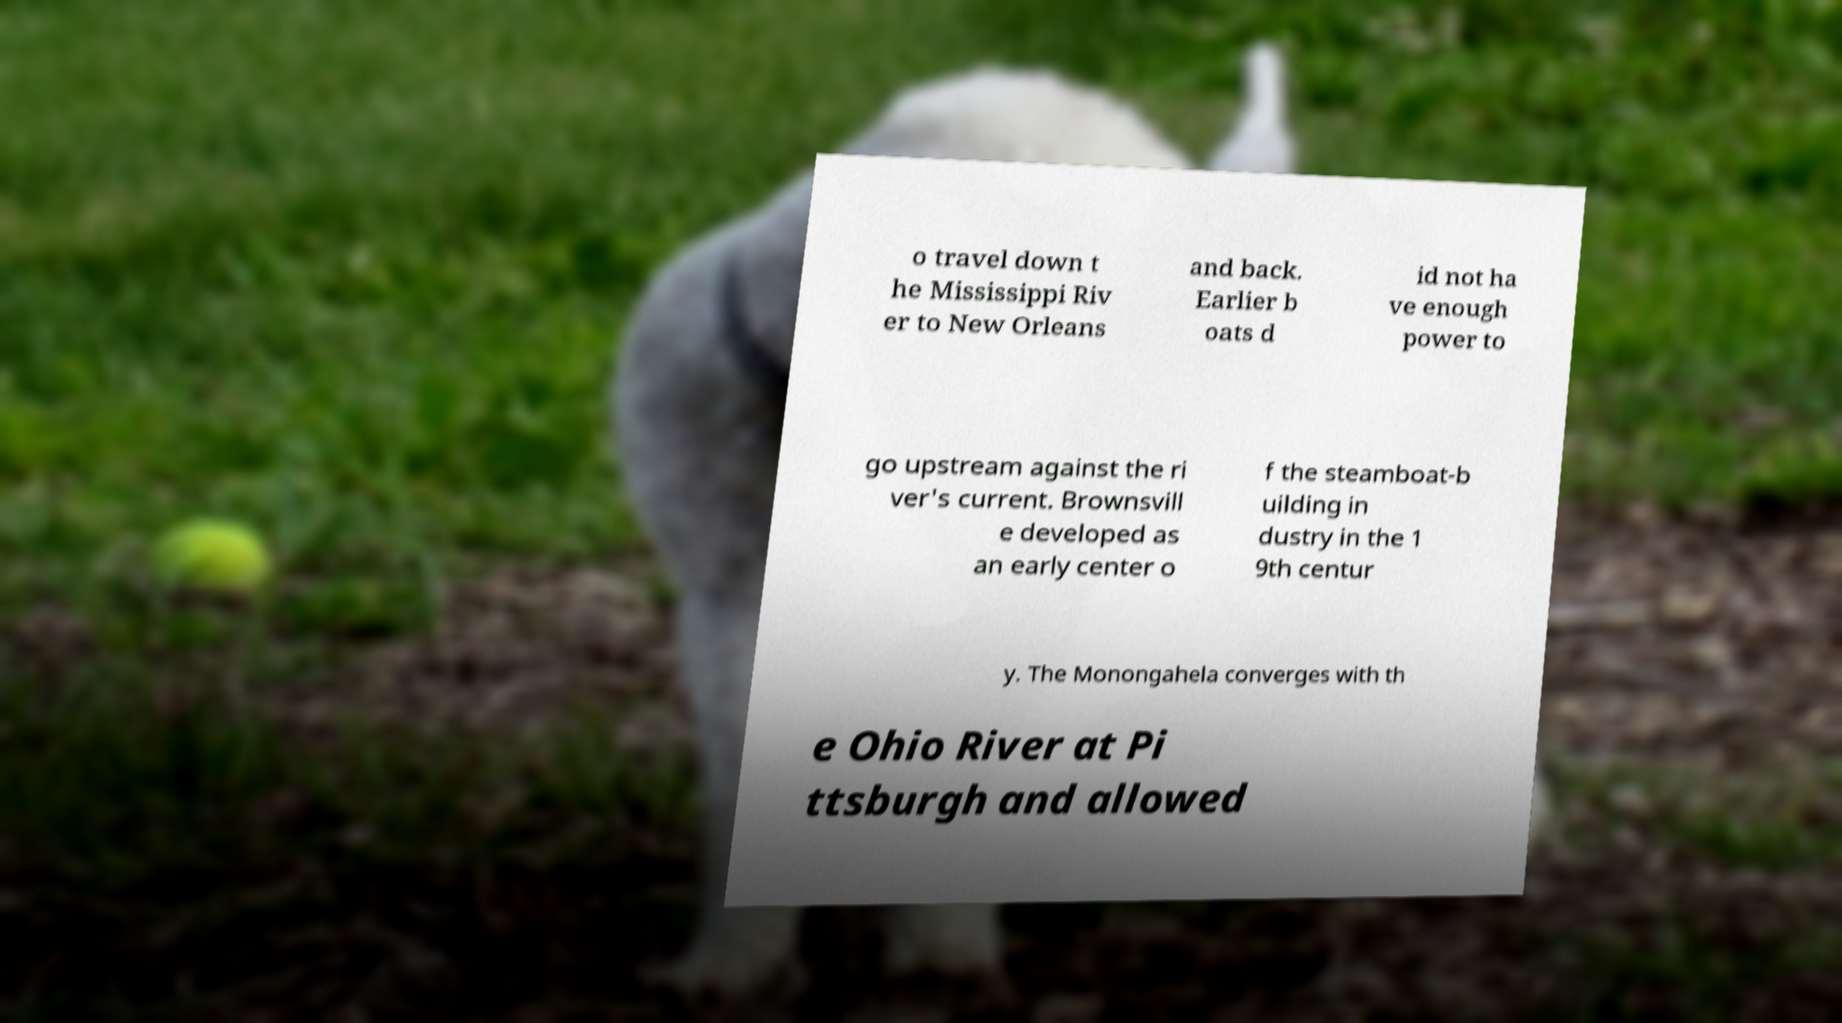What messages or text are displayed in this image? I need them in a readable, typed format. o travel down t he Mississippi Riv er to New Orleans and back. Earlier b oats d id not ha ve enough power to go upstream against the ri ver's current. Brownsvill e developed as an early center o f the steamboat-b uilding in dustry in the 1 9th centur y. The Monongahela converges with th e Ohio River at Pi ttsburgh and allowed 